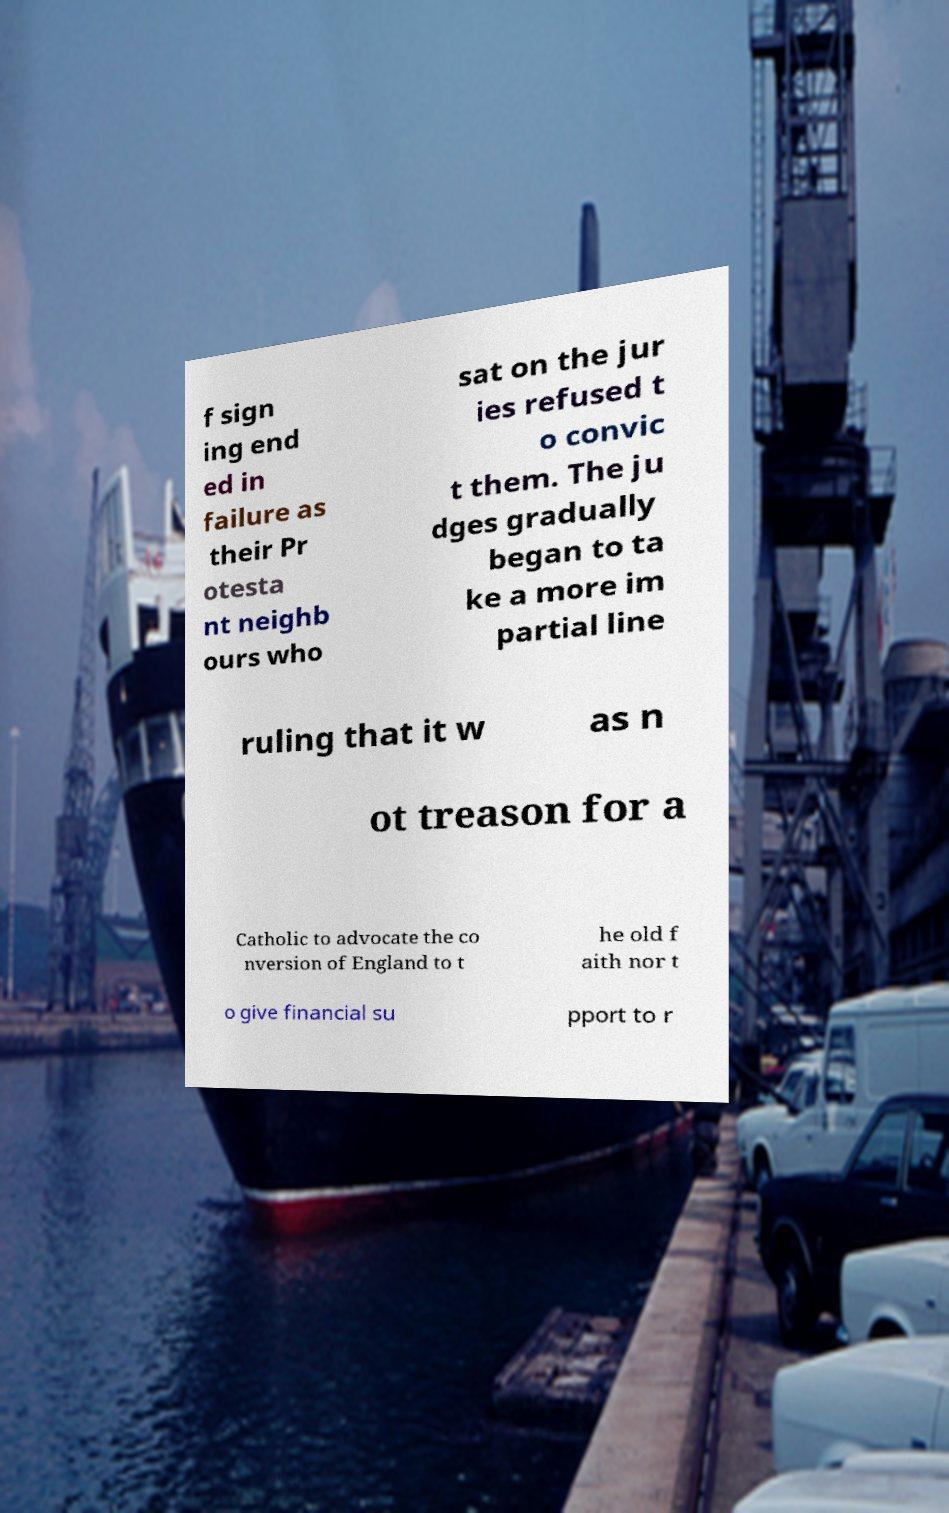Please identify and transcribe the text found in this image. f sign ing end ed in failure as their Pr otesta nt neighb ours who sat on the jur ies refused t o convic t them. The ju dges gradually began to ta ke a more im partial line ruling that it w as n ot treason for a Catholic to advocate the co nversion of England to t he old f aith nor t o give financial su pport to r 